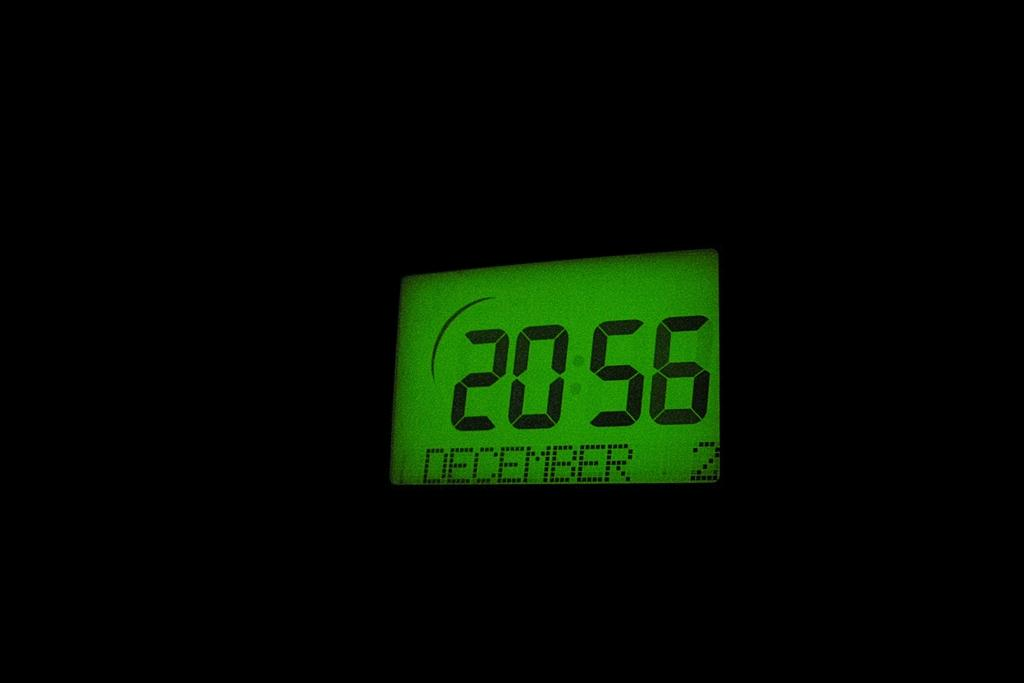Provide a one-sentence caption for the provided image. A digital clock showing the time is 20:56 on December 2. 